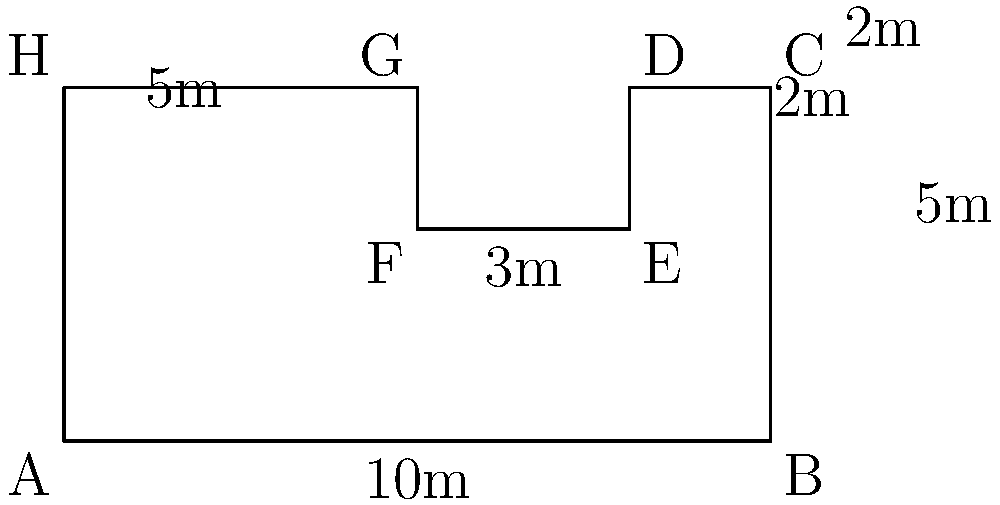As an architecture critic, you're reviewing a new avant-garde building in London. The floor plan of the main level is an irregular polygon, as shown in the diagram. Calculate the total floor area of this level in square meters. To calculate the total floor area, we need to divide the irregular polygon into simpler shapes and sum their areas. Let's approach this step-by-step:

1. Divide the floor plan into three rectangles:
   a. Rectangle ABCH: 10m x 5m
   b. Rectangle DEFG: 3m x 2m
   c. Rectangle EFGH: 5m x 3m

2. Calculate the areas:
   a. Area of ABCH: $A_1 = 10m \times 5m = 50m^2$
   b. Area of DEFG: $A_2 = 3m \times 2m = 6m^2$
   c. Area of EFGH: $A_3 = 5m \times 3m = 15m^2$

3. Sum the areas:
   Total Area = $A_1 + A_2 + A_3$
   $= 50m^2 + 6m^2 + 15m^2$
   $= 71m^2$

Therefore, the total floor area of the main level is 71 square meters.
Answer: 71 $m^2$ 